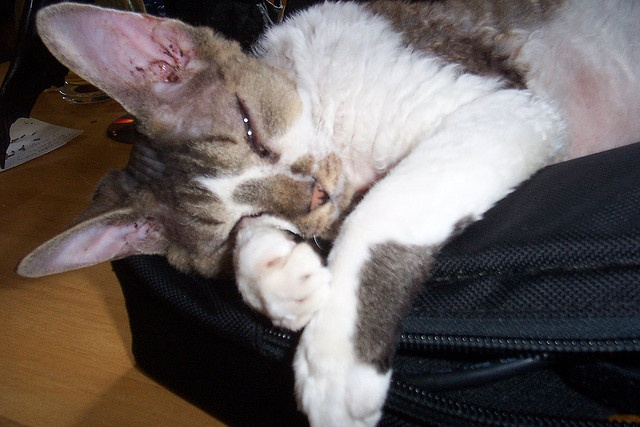Describe the objects in this image and their specific colors. I can see cat in black, lightgray, darkgray, and gray tones, suitcase in black, darkblue, and gray tones, and cup in black, maroon, and gray tones in this image. 